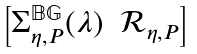Convert formula to latex. <formula><loc_0><loc_0><loc_500><loc_500>\begin{bmatrix} \Sigma _ { \eta , P } ^ { \mathbb { B G } } ( \lambda ) & \mathcal { R } _ { \eta , P } \end{bmatrix}</formula> 